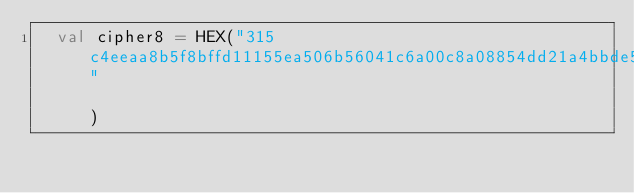Convert code to text. <code><loc_0><loc_0><loc_500><loc_500><_Scala_>  val cipher8 = HEX("315c4eeaa8b5f8bffd11155ea506b56041c6a00c8a08854dd21a4bbde54ce56801d943ba708b8a3574f40c00fff9e00fa1439fd0654327a3bfc860b92f89ee04132ecb9298f5fd2d5e4b45e40ecc3b9d59e9417df7c95bba410e9aa2ca24c5474da2f276baa3ac325918b2daada43d6712150441c2e04f6565517f317da9d3"                                                                                                                       )</code> 